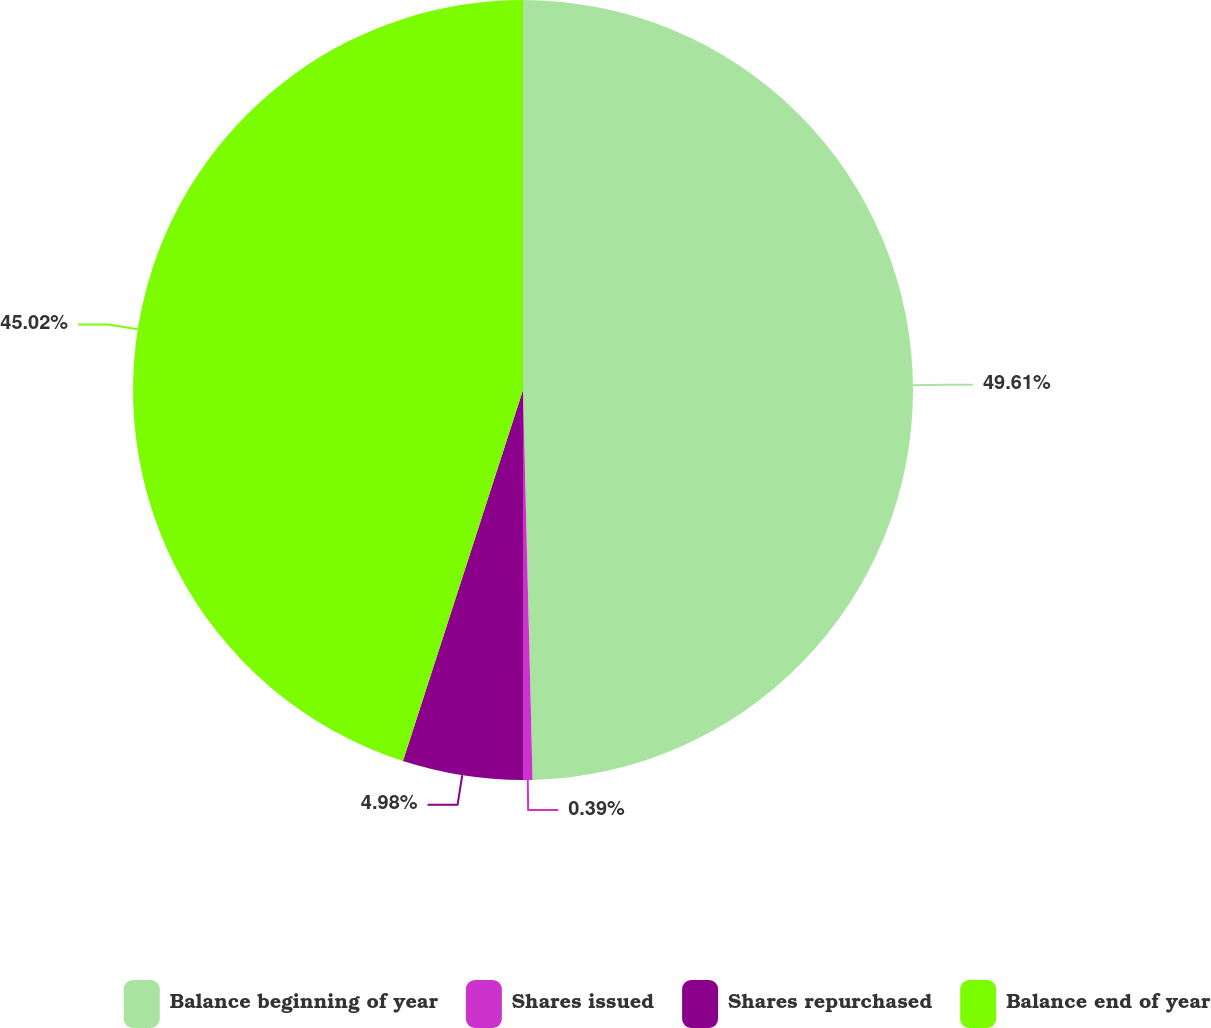Convert chart to OTSL. <chart><loc_0><loc_0><loc_500><loc_500><pie_chart><fcel>Balance beginning of year<fcel>Shares issued<fcel>Shares repurchased<fcel>Balance end of year<nl><fcel>49.61%<fcel>0.39%<fcel>4.98%<fcel>45.02%<nl></chart> 